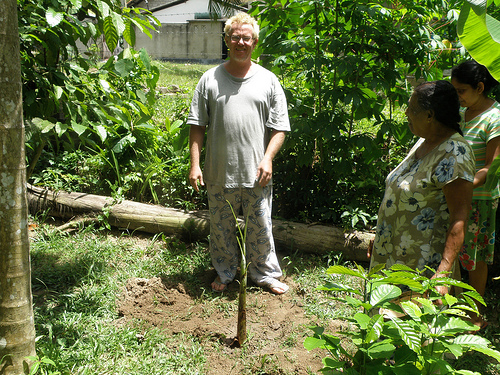<image>
Can you confirm if the tree is behind the woman? Yes. From this viewpoint, the tree is positioned behind the woman, with the woman partially or fully occluding the tree. Where is the soil in relation to the nighty? Is it in front of the nighty? Yes. The soil is positioned in front of the nighty, appearing closer to the camera viewpoint. 